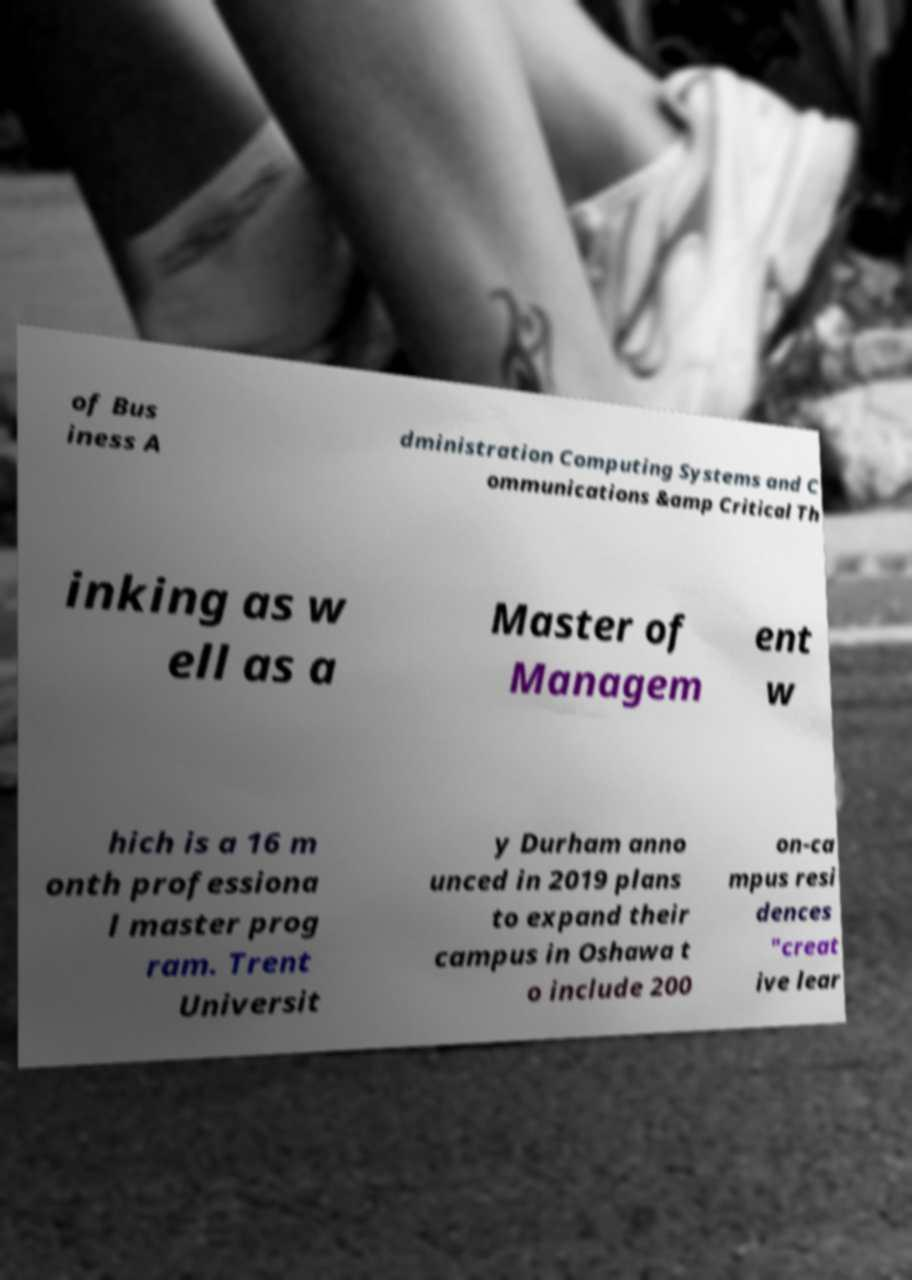Can you accurately transcribe the text from the provided image for me? of Bus iness A dministration Computing Systems and C ommunications &amp Critical Th inking as w ell as a Master of Managem ent w hich is a 16 m onth professiona l master prog ram. Trent Universit y Durham anno unced in 2019 plans to expand their campus in Oshawa t o include 200 on-ca mpus resi dences "creat ive lear 